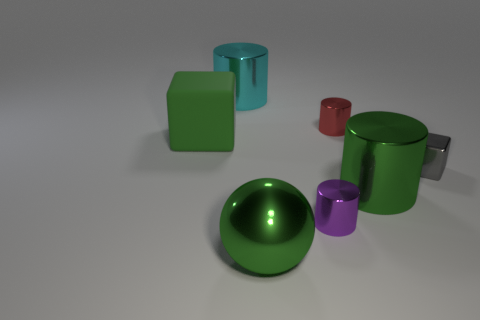What is the material of the block that is the same size as the green ball?
Offer a very short reply. Rubber. What material is the big cyan object that is the same shape as the purple metal thing?
Make the answer very short. Metal. What number of other things are there of the same size as the red cylinder?
Offer a terse response. 2. What size is the matte cube that is the same color as the sphere?
Your response must be concise. Large. How many small metal objects have the same color as the large block?
Make the answer very short. 0. What is the shape of the cyan thing?
Your answer should be compact. Cylinder. What is the color of the shiny object that is in front of the large cyan cylinder and behind the tiny block?
Offer a terse response. Red. What is the tiny gray cube made of?
Your answer should be compact. Metal. The tiny metal object that is right of the red object has what shape?
Keep it short and to the point. Cube. The metal sphere that is the same size as the matte block is what color?
Give a very brief answer. Green. 